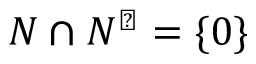<formula> <loc_0><loc_0><loc_500><loc_500>N \cap N ^ { \perp } = \{ 0 \}</formula> 